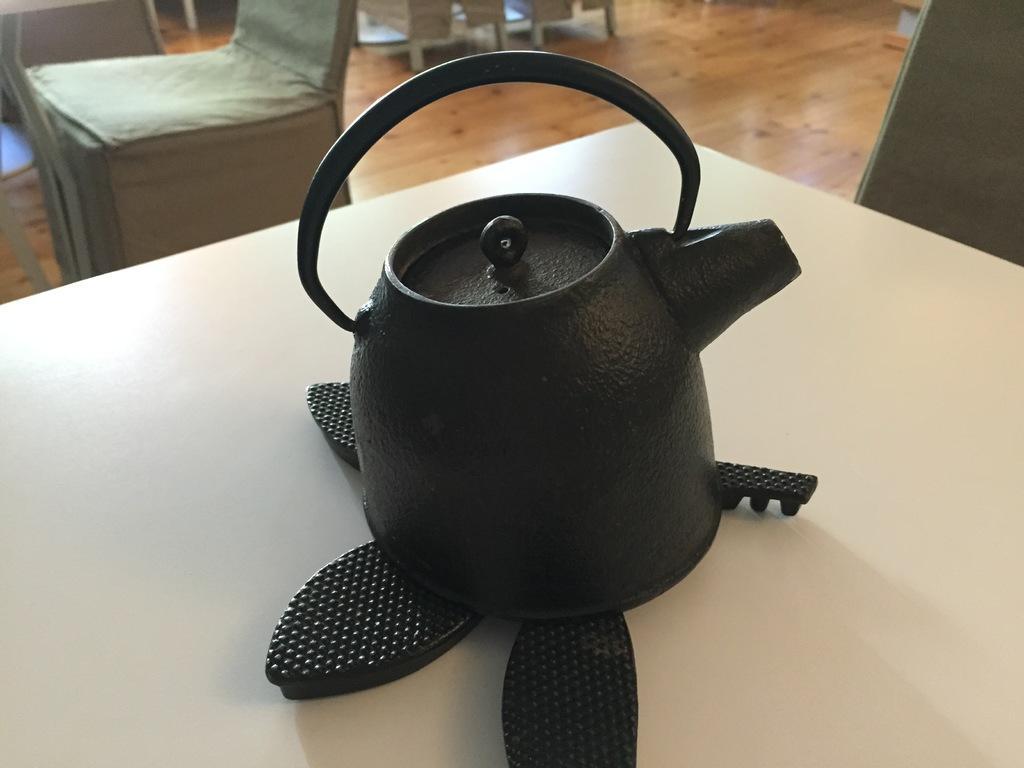How would you summarize this image in a sentence or two? In this picture we can see a tea pot on the platform and in the background we can see some objects on the floor. 